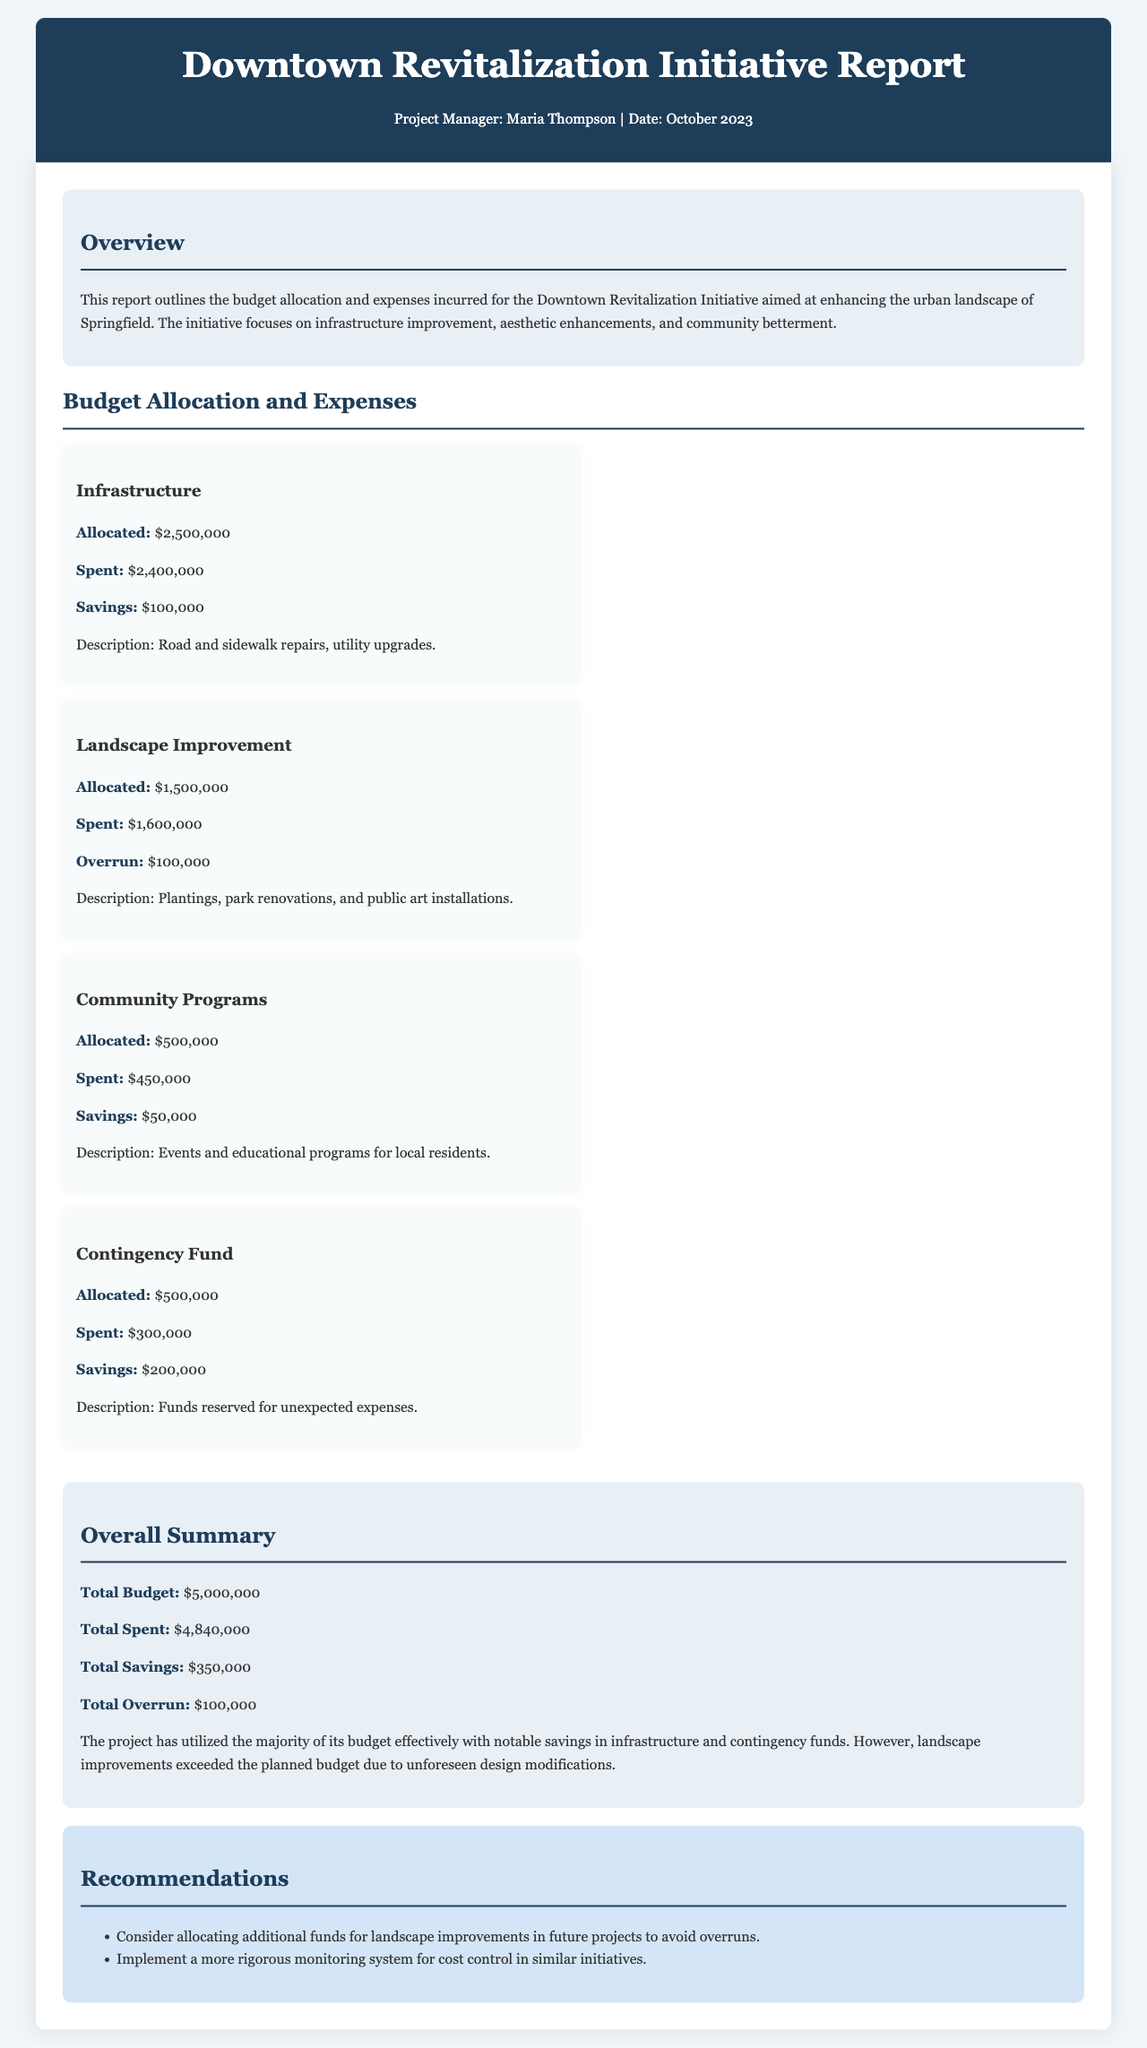what is the total budget? The total budget is explicitly mentioned in the document as $5,000,000.
Answer: $5,000,000 what was spent on landscape improvement? The document states that $1,600,000 was spent on landscape improvement, indicating an overrun.
Answer: $1,600,000 how much was saved in the contingency fund? The savings in the contingency fund are detailed in the report as $200,000.
Answer: $200,000 who is the project manager? The document lists Maria Thompson as the project manager responsible for the initiative.
Answer: Maria Thompson what is the total overrun amount? The total overrun is explicitly noted in the summary of the report as $100,000.
Answer: $100,000 how much was allocated for community programs? The report specifies that $500,000 was allocated for community programs.
Answer: $500,000 what is recommended for future projects regarding landscape improvements? The recommendation suggests considering additional fund allocation for landscape improvements in future projects to prevent overruns.
Answer: Additional funds how much was spent in total for the initiative? The total amount spent for the initiative is stated in the summary as $4,840,000.
Answer: $4,840,000 what type of enhancements does the initiative focus on? The initiative focuses on infrastructure improvement, aesthetic enhancements, and community betterment.
Answer: Infrastructure improvement, aesthetic enhancements, community betterment 